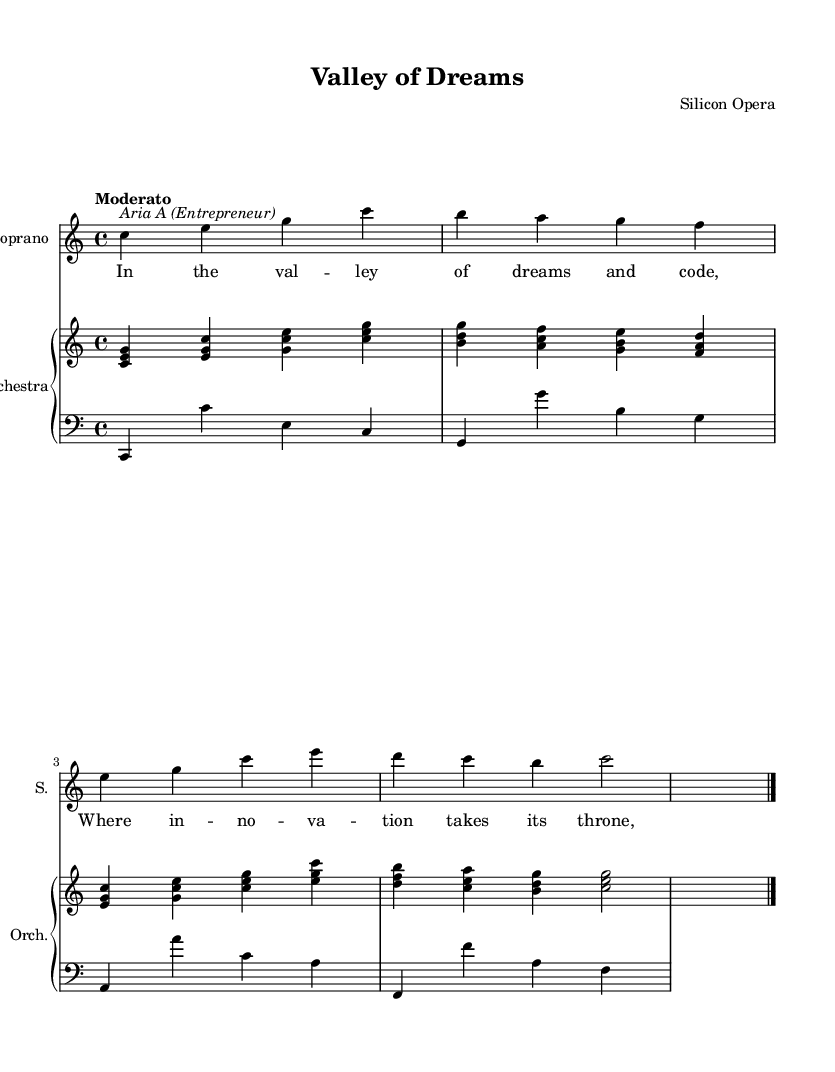What is the title of this opera? The title is displayed prominently at the top of the sheet music as "Valley of Dreams".
Answer: Valley of Dreams What is the key signature of this music? The key signature is indicated in the global section and corresponds to C major, which has no sharps or flats.
Answer: C major What is the tempo marking for this piece? The tempo marking is given as "Moderato", referring to a moderate pace.
Answer: Moderato How many measures does the soprano part contain? By counting the bar lines in the soprano part, there are five measures.
Answer: Five What instrument group accompanies the soprano? The sheet music features an orchestral accompaniment, as noted in the lower staff section labeled "Orchestra".
Answer: Orchestra What dynamic marking is indicated for the soprano? The soprano part includes a dynamic marking "Up", which indicates to play the dynamics upwards in the musical expression.
Answer: Up What is the theme of the soprano's aria? The lyrics of the soprano's aria focus on themes of innovation and perseverance in the context of building an app.
Answer: Innovation and perseverance 